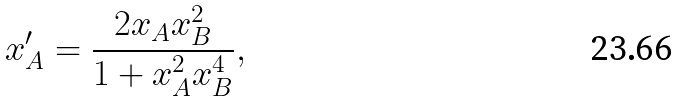<formula> <loc_0><loc_0><loc_500><loc_500>x _ { A } ^ { \prime } = \frac { 2 x _ { A } x _ { B } ^ { 2 } } { 1 + x _ { A } ^ { 2 } x _ { B } ^ { 4 } } ,</formula> 